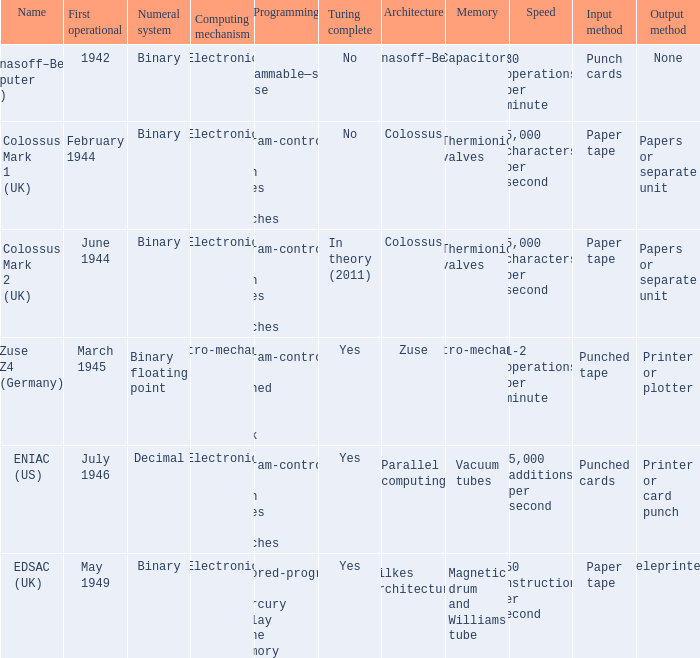What's the turing complete with numeral system being decimal Yes. 